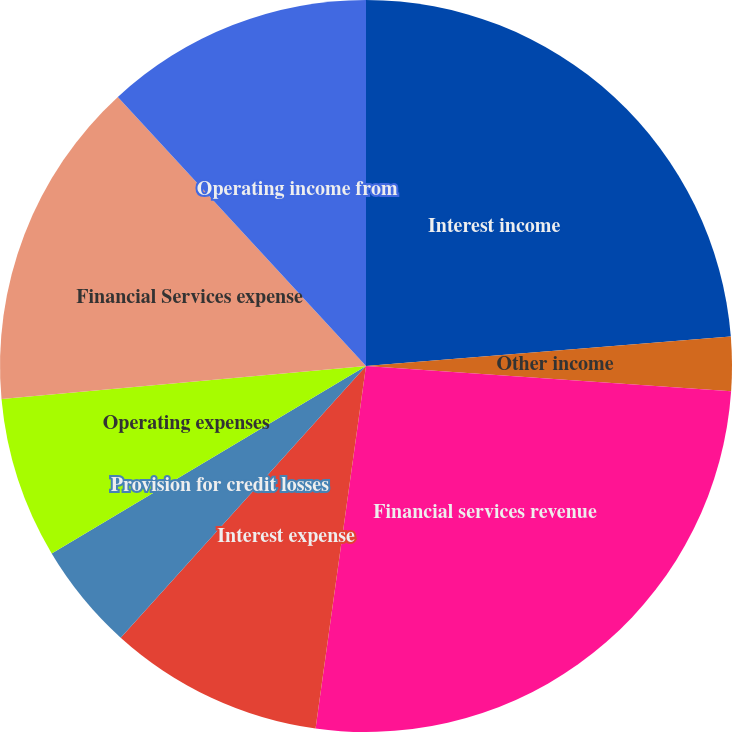Convert chart. <chart><loc_0><loc_0><loc_500><loc_500><pie_chart><fcel>Interest income<fcel>Other income<fcel>Financial services revenue<fcel>Interest expense<fcel>Provision for credit losses<fcel>Operating expenses<fcel>Financial Services expense<fcel>Operating income from<nl><fcel>23.72%<fcel>2.38%<fcel>26.1%<fcel>9.49%<fcel>4.75%<fcel>7.12%<fcel>14.58%<fcel>11.86%<nl></chart> 